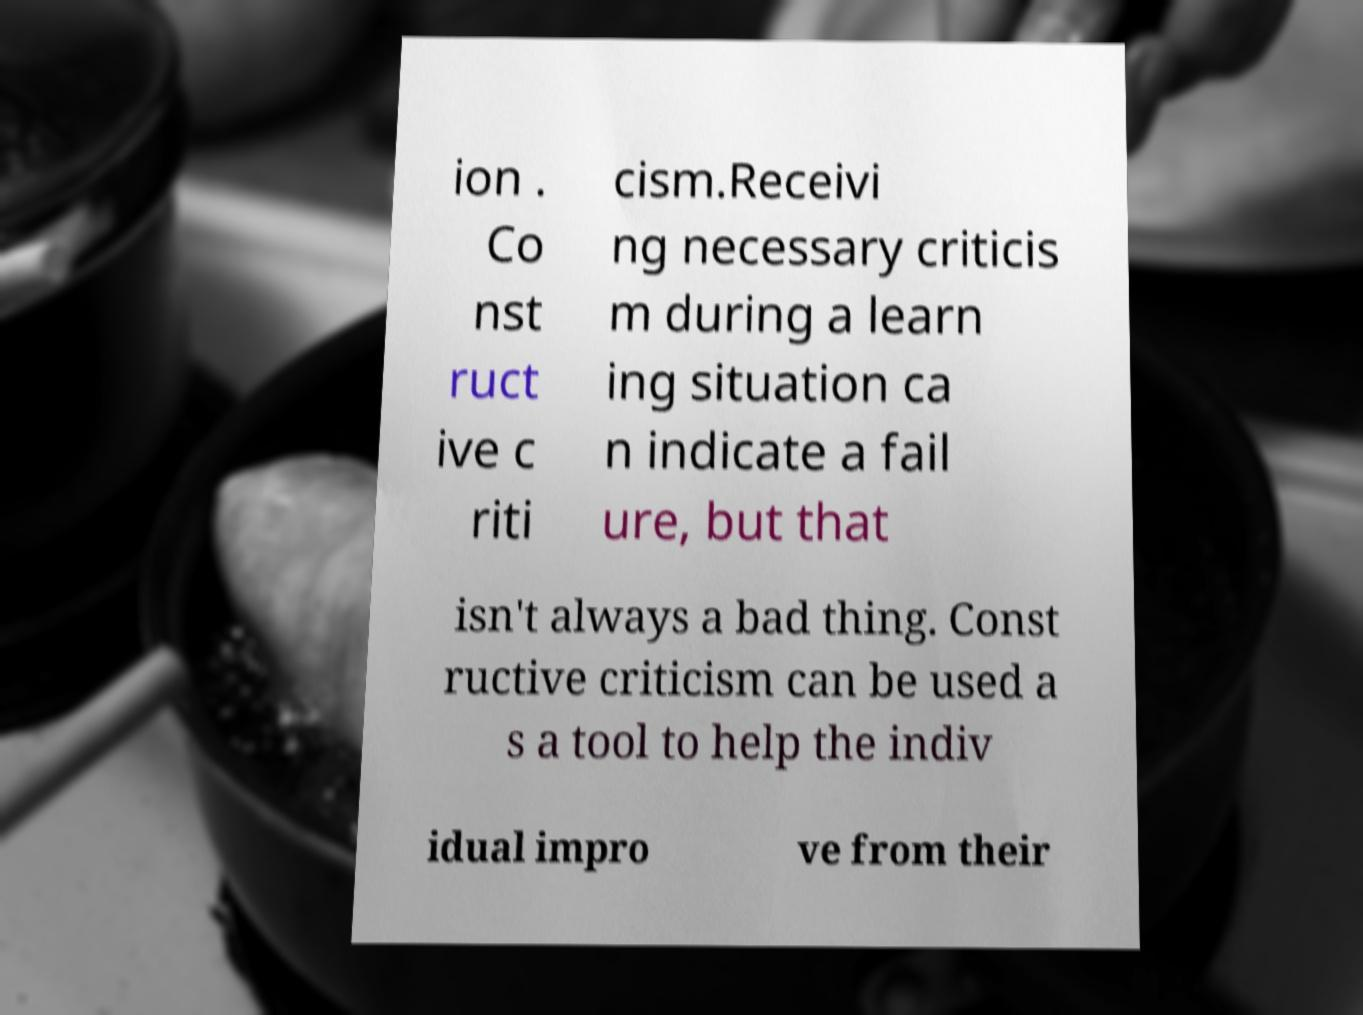Can you read and provide the text displayed in the image?This photo seems to have some interesting text. Can you extract and type it out for me? ion . Co nst ruct ive c riti cism.Receivi ng necessary criticis m during a learn ing situation ca n indicate a fail ure, but that isn't always a bad thing. Const ructive criticism can be used a s a tool to help the indiv idual impro ve from their 